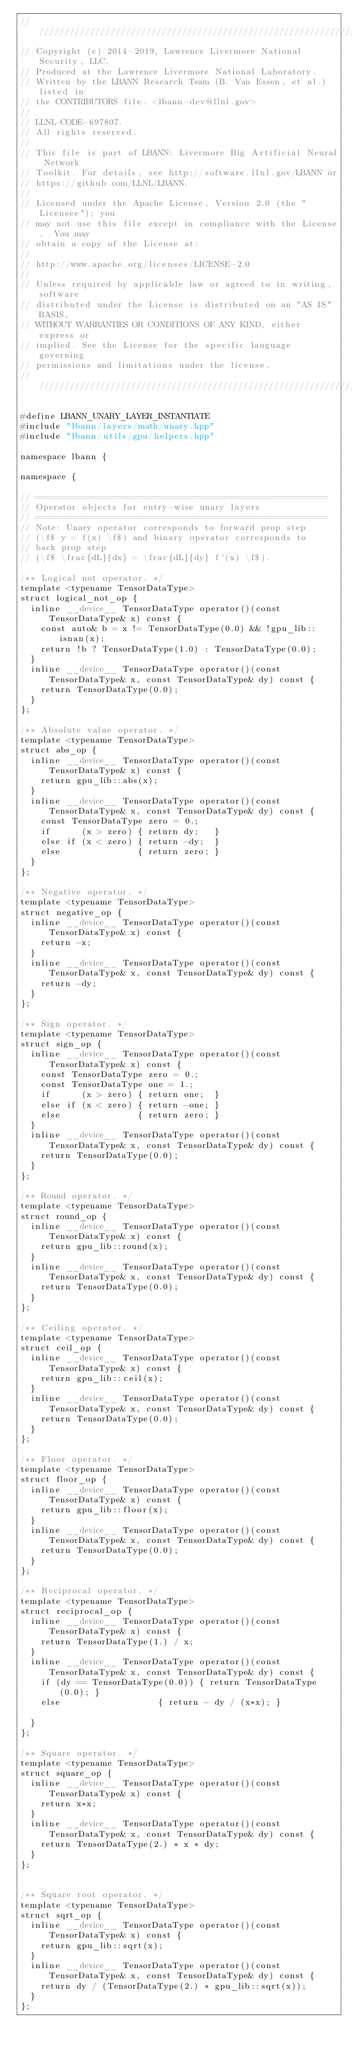Convert code to text. <code><loc_0><loc_0><loc_500><loc_500><_Cuda_>////////////////////////////////////////////////////////////////////////////////
// Copyright (c) 2014-2019, Lawrence Livermore National Security, LLC.
// Produced at the Lawrence Livermore National Laboratory.
// Written by the LBANN Research Team (B. Van Essen, et al.) listed in
// the CONTRIBUTORS file. <lbann-dev@llnl.gov>
//
// LLNL-CODE-697807.
// All rights reserved.
//
// This file is part of LBANN: Livermore Big Artificial Neural Network
// Toolkit. For details, see http://software.llnl.gov/LBANN or
// https://github.com/LLNL/LBANN.
//
// Licensed under the Apache License, Version 2.0 (the "Licensee"); you
// may not use this file except in compliance with the License.  You may
// obtain a copy of the License at:
//
// http://www.apache.org/licenses/LICENSE-2.0
//
// Unless required by applicable law or agreed to in writing, software
// distributed under the License is distributed on an "AS IS" BASIS,
// WITHOUT WARRANTIES OR CONDITIONS OF ANY KIND, either express or
// implied. See the License for the specific language governing
// permissions and limitations under the license.
////////////////////////////////////////////////////////////////////////////////

#define LBANN_UNARY_LAYER_INSTANTIATE
#include "lbann/layers/math/unary.hpp"
#include "lbann/utils/gpu/helpers.hpp"

namespace lbann {

namespace {

// =========================================================
// Operator objects for entry-wise unary layers
// =========================================================
// Note: Unary operator corresponds to forward prop step
// (\f$ y = f(x) \f$) and binary operator corresponds to
// back prop step
// (\f$ \frac{dL}{dx} = \frac{dL}{dy} f'(x) \f$).

/** Logical not operator. */
template <typename TensorDataType>
struct logical_not_op {
  inline __device__ TensorDataType operator()(const TensorDataType& x) const {
    const auto& b = x != TensorDataType(0.0) && !gpu_lib::isnan(x);
    return !b ? TensorDataType(1.0) : TensorDataType(0.0);
  }
  inline __device__ TensorDataType operator()(const TensorDataType& x, const TensorDataType& dy) const {
    return TensorDataType(0.0);
  }
};

/** Absolute value operator. */
template <typename TensorDataType>
struct abs_op {
  inline __device__ TensorDataType operator()(const TensorDataType& x) const {
    return gpu_lib::abs(x);
  }
  inline __device__ TensorDataType operator()(const TensorDataType& x, const TensorDataType& dy) const {
    const TensorDataType zero = 0.;
    if      (x > zero) { return dy;   }
    else if (x < zero) { return -dy;  }
    else               { return zero; }
  }
};

/** Negative operator. */
template <typename TensorDataType>
struct negative_op {
  inline __device__ TensorDataType operator()(const TensorDataType& x) const {
    return -x;
  }
  inline __device__ TensorDataType operator()(const TensorDataType& x, const TensorDataType& dy) const {
    return -dy;
  }
};

/** Sign operator. */
template <typename TensorDataType>
struct sign_op {
  inline __device__ TensorDataType operator()(const TensorDataType& x) const {
    const TensorDataType zero = 0.;
    const TensorDataType one = 1.;
    if      (x > zero) { return one;  }
    else if (x < zero) { return -one; }
    else               { return zero; }
  }
  inline __device__ TensorDataType operator()(const TensorDataType& x, const TensorDataType& dy) const {
    return TensorDataType(0.0);
  }
};

/** Round operator. */
template <typename TensorDataType>
struct round_op {
  inline __device__ TensorDataType operator()(const TensorDataType& x) const {
    return gpu_lib::round(x);
  }
  inline __device__ TensorDataType operator()(const TensorDataType& x, const TensorDataType& dy) const {
    return TensorDataType(0.0);
  }
};

/** Ceiling operator. */
template <typename TensorDataType>
struct ceil_op {
  inline __device__ TensorDataType operator()(const TensorDataType& x) const {
    return gpu_lib::ceil(x);
  }
  inline __device__ TensorDataType operator()(const TensorDataType& x, const TensorDataType& dy) const {
    return TensorDataType(0.0);
  }
};

/** Floor operator. */
template <typename TensorDataType>
struct floor_op {
  inline __device__ TensorDataType operator()(const TensorDataType& x) const {
    return gpu_lib::floor(x);
  }
  inline __device__ TensorDataType operator()(const TensorDataType& x, const TensorDataType& dy) const {
    return TensorDataType(0.0);
  }
};

/** Reciprocal operator. */
template <typename TensorDataType>
struct reciprocal_op {
  inline __device__ TensorDataType operator()(const TensorDataType& x) const {
    return TensorDataType(1.) / x;
  }
  inline __device__ TensorDataType operator()(const TensorDataType& x, const TensorDataType& dy) const {
    if (dy == TensorDataType(0.0)) { return TensorDataType(0.0); }
    else                   { return - dy / (x*x); }

  }
};

/** Square operator. */
template <typename TensorDataType>
struct square_op {
  inline __device__ TensorDataType operator()(const TensorDataType& x) const {
    return x*x;
  }
  inline __device__ TensorDataType operator()(const TensorDataType& x, const TensorDataType& dy) const {
    return TensorDataType(2.) * x * dy;
  }
};


/** Square root operator. */
template <typename TensorDataType>
struct sqrt_op {
  inline __device__ TensorDataType operator()(const TensorDataType& x) const {
    return gpu_lib::sqrt(x);
  }
  inline __device__ TensorDataType operator()(const TensorDataType& x, const TensorDataType& dy) const {
    return dy / (TensorDataType(2.) * gpu_lib::sqrt(x));
  }
};
</code> 